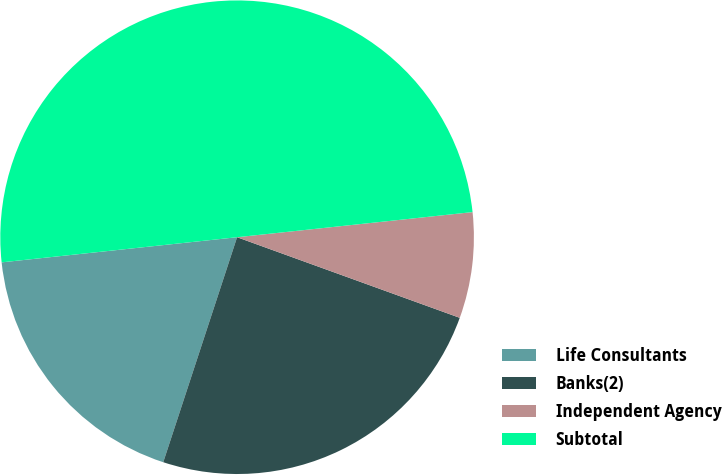Convert chart. <chart><loc_0><loc_0><loc_500><loc_500><pie_chart><fcel>Life Consultants<fcel>Banks(2)<fcel>Independent Agency<fcel>Subtotal<nl><fcel>18.26%<fcel>24.52%<fcel>7.22%<fcel>50.0%<nl></chart> 